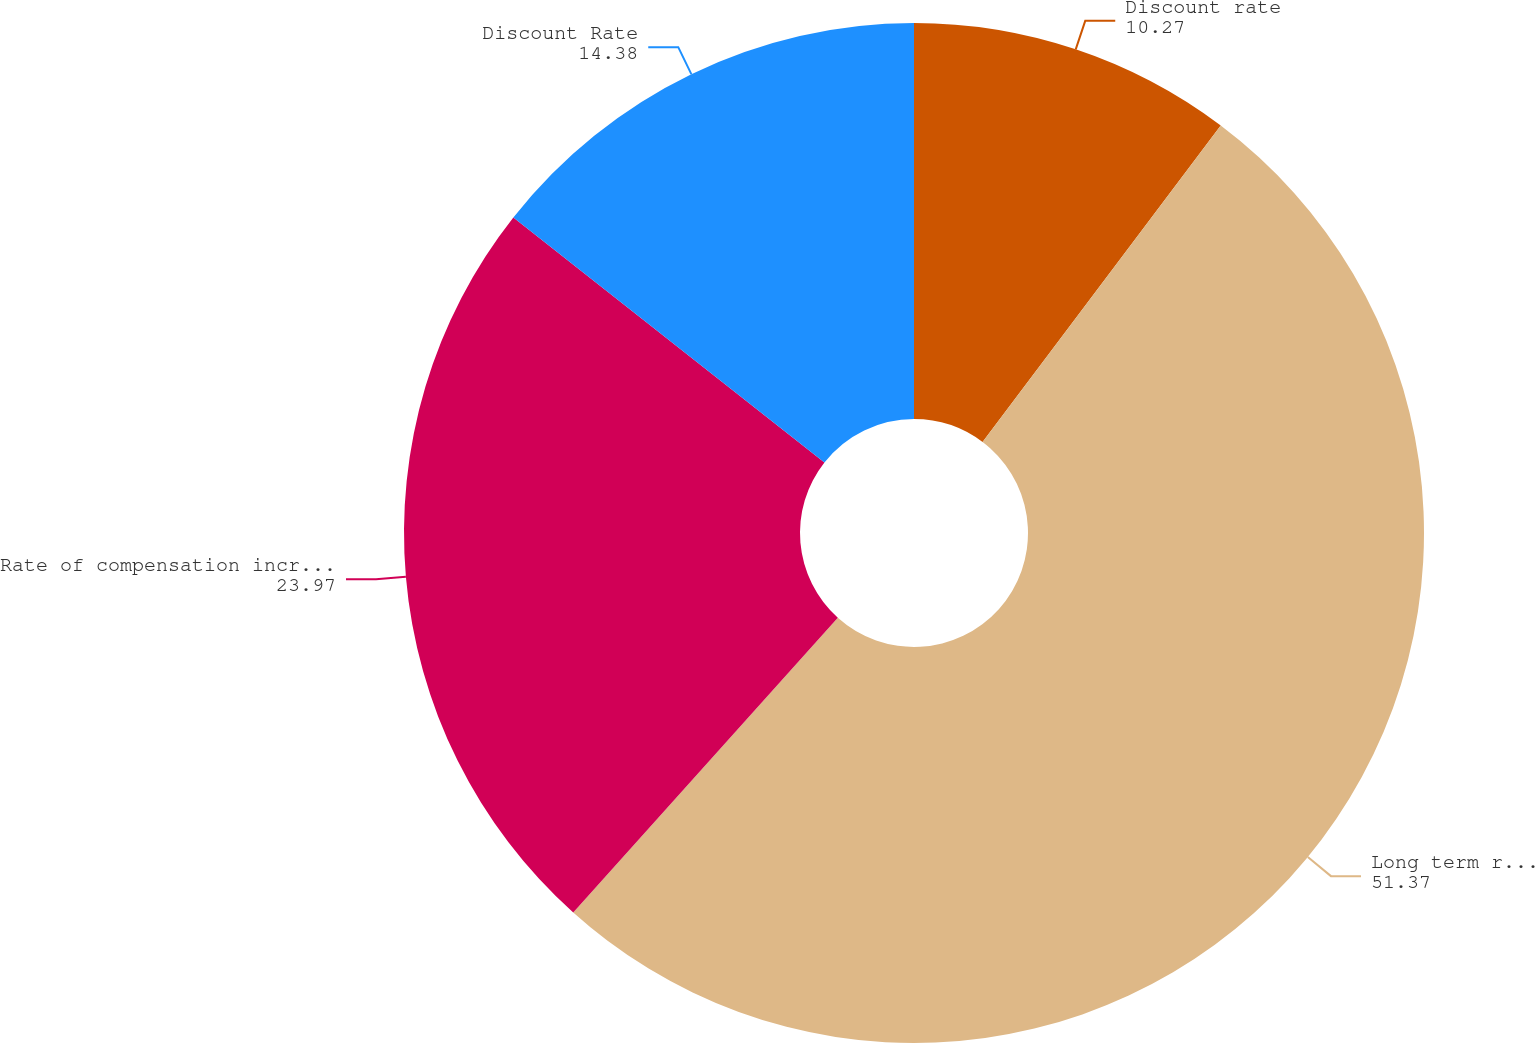<chart> <loc_0><loc_0><loc_500><loc_500><pie_chart><fcel>Discount rate<fcel>Long term rate of return on<fcel>Rate of compensation increase<fcel>Discount Rate<nl><fcel>10.27%<fcel>51.37%<fcel>23.97%<fcel>14.38%<nl></chart> 